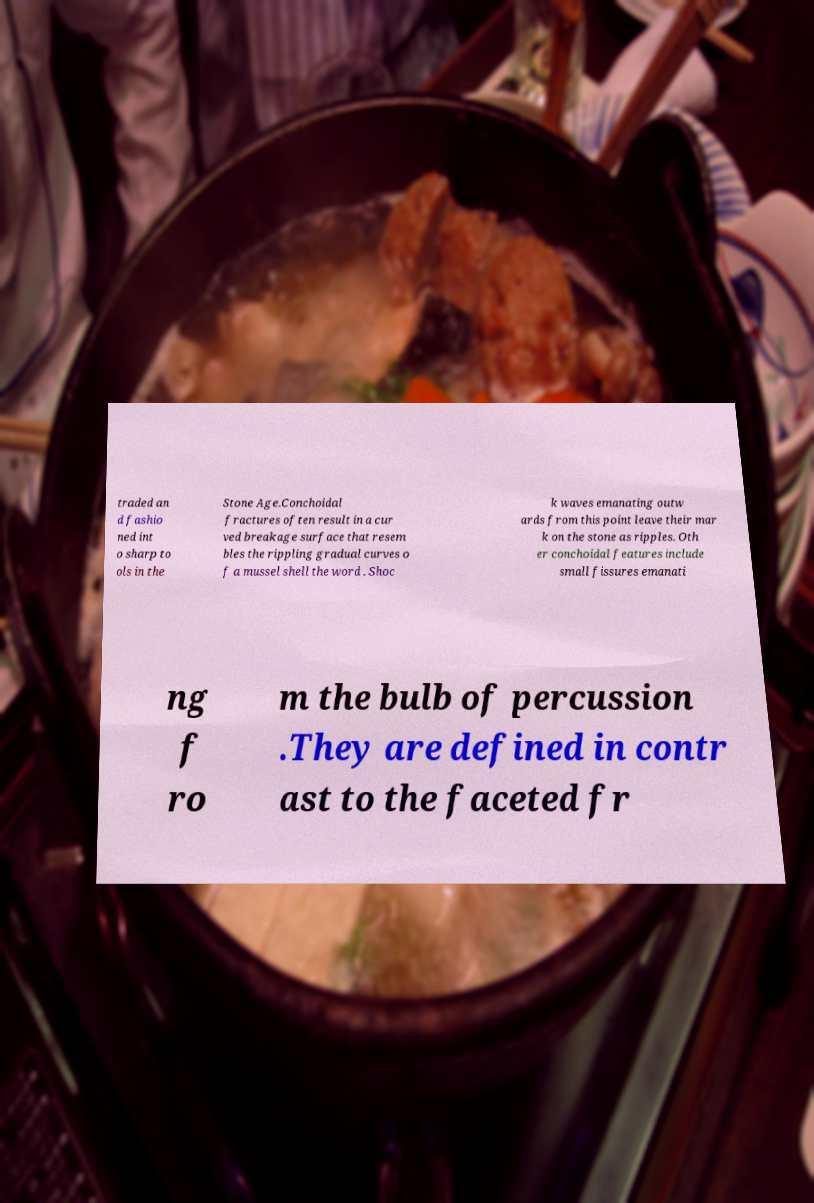Could you extract and type out the text from this image? traded an d fashio ned int o sharp to ols in the Stone Age.Conchoidal fractures often result in a cur ved breakage surface that resem bles the rippling gradual curves o f a mussel shell the word . Shoc k waves emanating outw ards from this point leave their mar k on the stone as ripples. Oth er conchoidal features include small fissures emanati ng f ro m the bulb of percussion .They are defined in contr ast to the faceted fr 